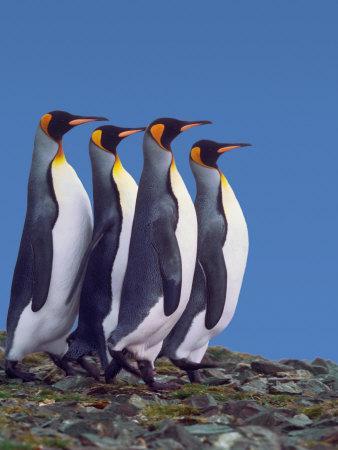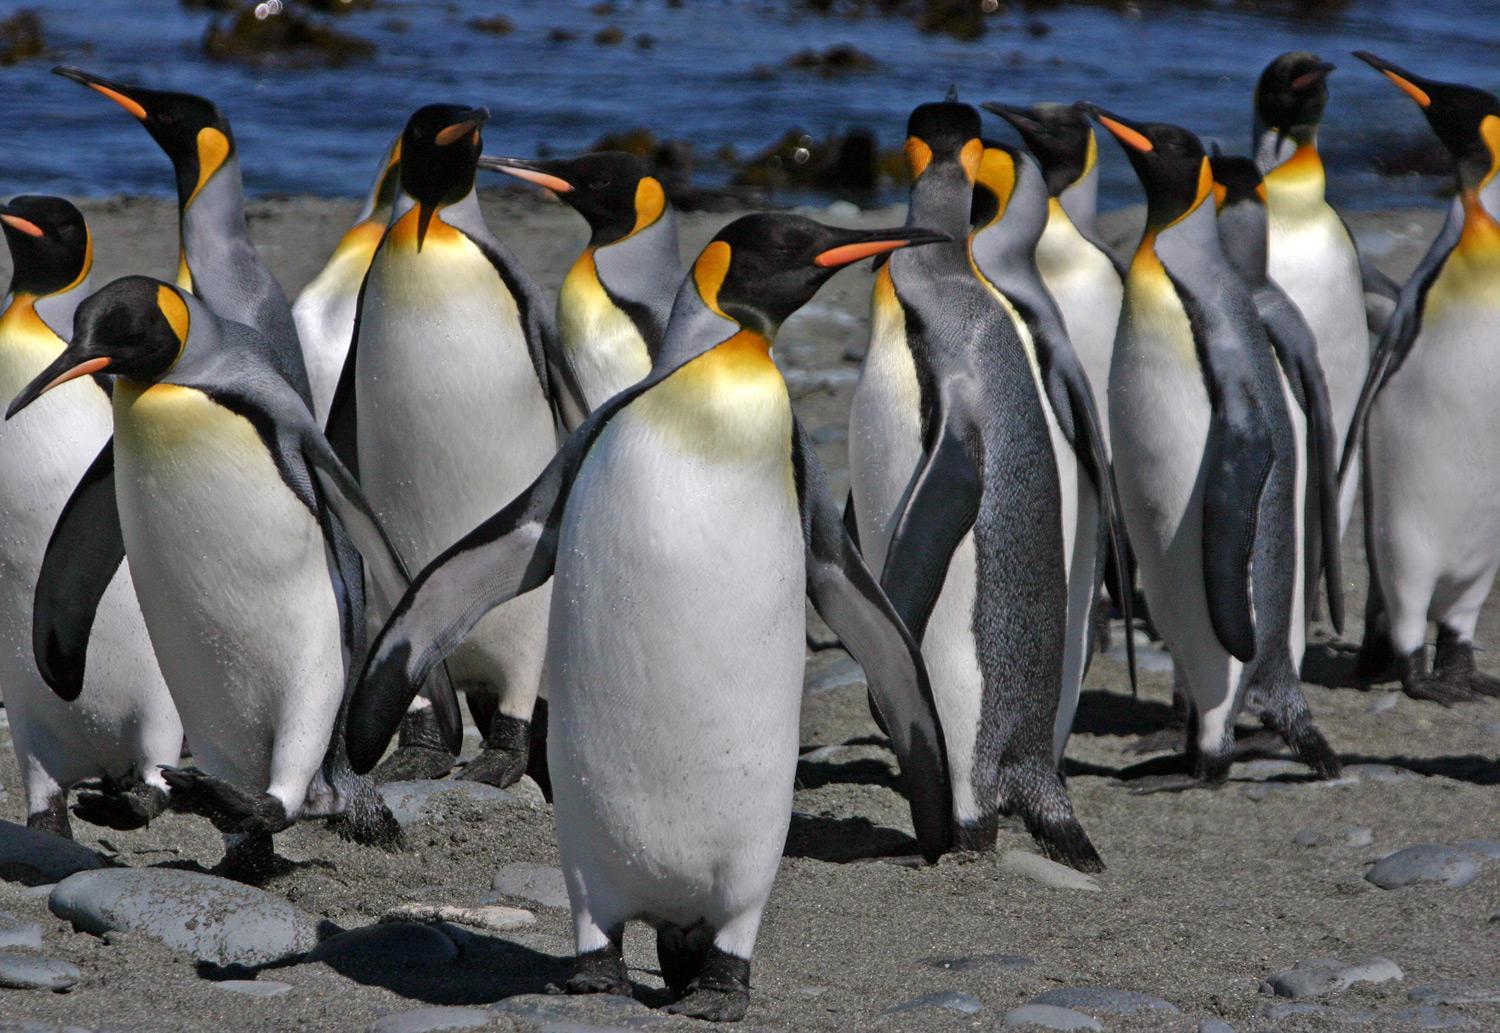The first image is the image on the left, the second image is the image on the right. Analyze the images presented: Is the assertion "The penguins in the image on the right are walking across the snow." valid? Answer yes or no. No. The first image is the image on the left, the second image is the image on the right. Assess this claim about the two images: "An image shows a row of no more than six upright penguins, all facing right.". Correct or not? Answer yes or no. Yes. 